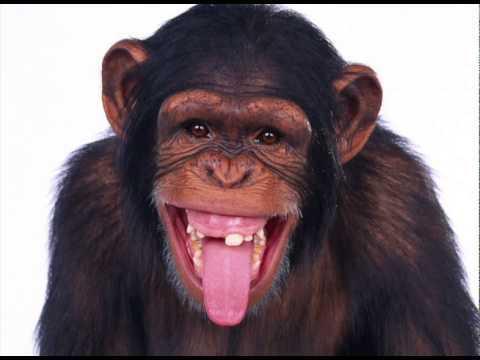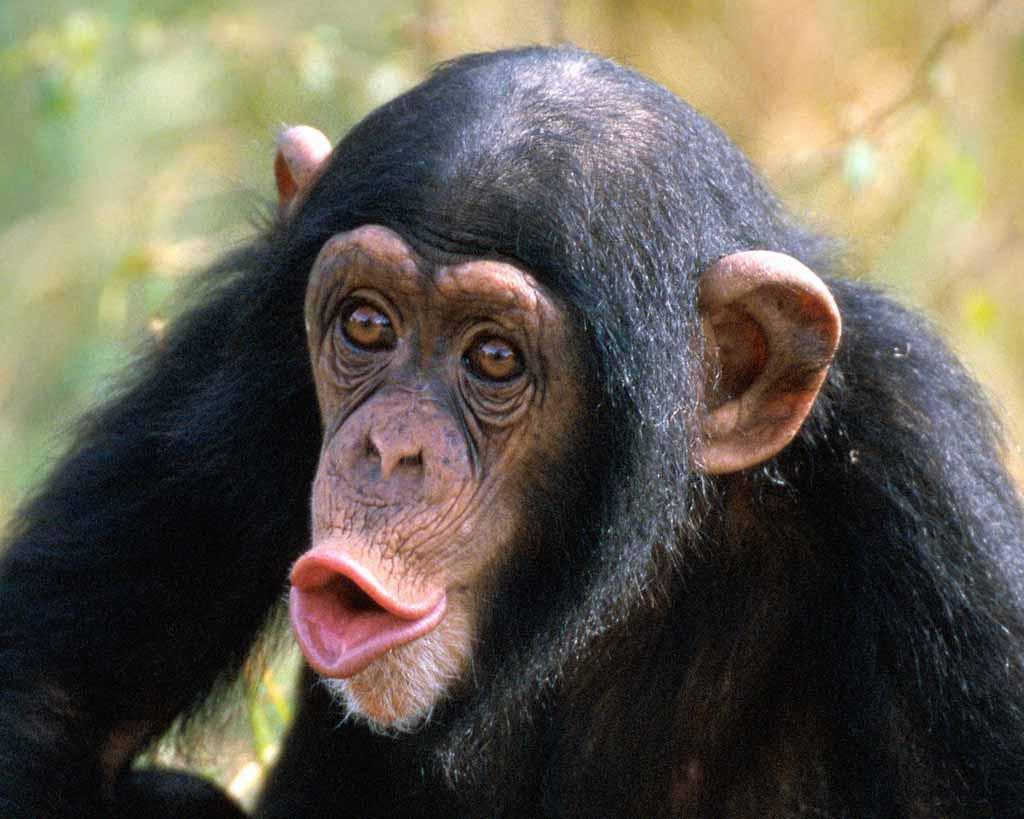The first image is the image on the left, the second image is the image on the right. Examine the images to the left and right. Is the description "There are multiple chimps outside in the image on the right." accurate? Answer yes or no. No. The first image is the image on the left, the second image is the image on the right. Considering the images on both sides, is "An image contains one chimp, with arms folded across its chest and a wide, open grin on its face." valid? Answer yes or no. No. 